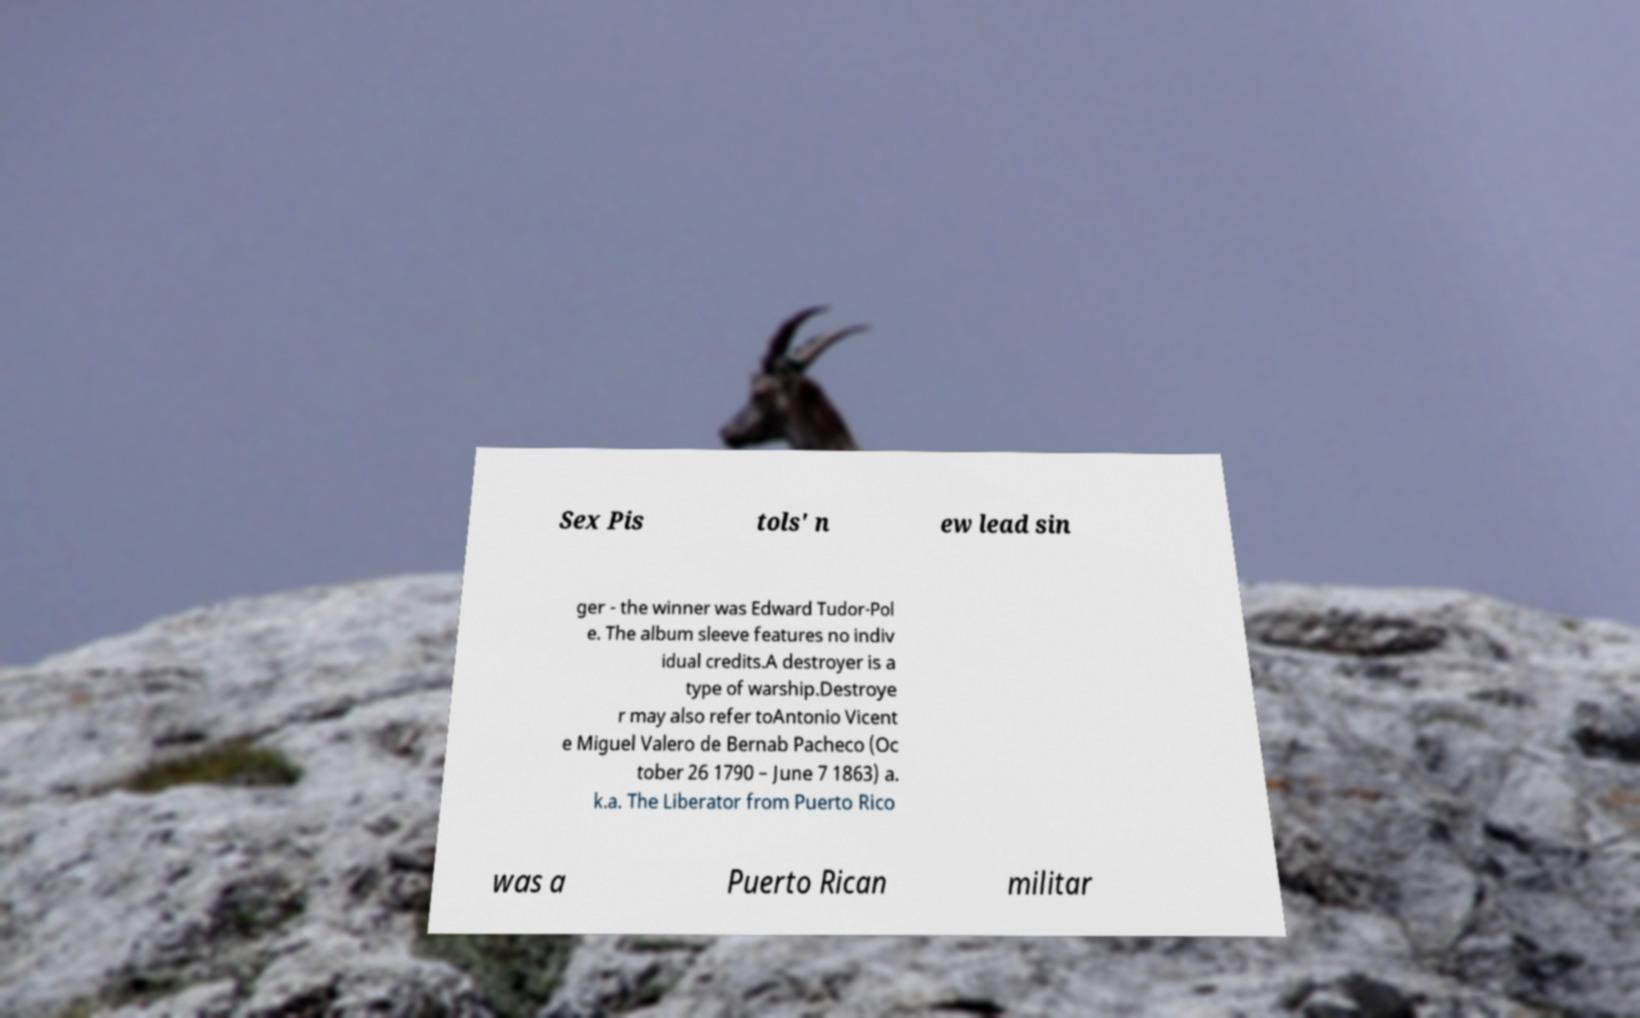Could you extract and type out the text from this image? Sex Pis tols' n ew lead sin ger - the winner was Edward Tudor-Pol e. The album sleeve features no indiv idual credits.A destroyer is a type of warship.Destroye r may also refer toAntonio Vicent e Miguel Valero de Bernab Pacheco (Oc tober 26 1790 – June 7 1863) a. k.a. The Liberator from Puerto Rico was a Puerto Rican militar 